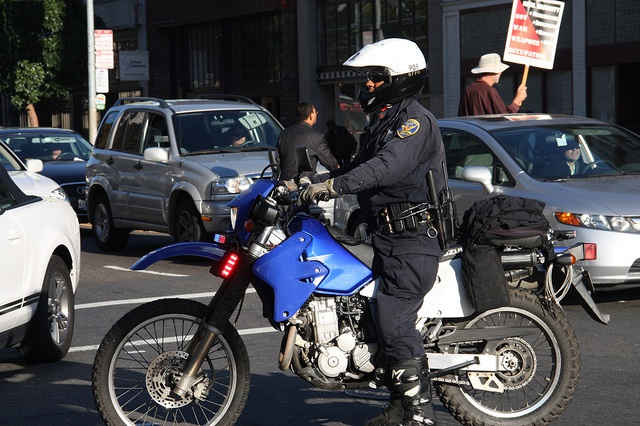Describe the objects in this image and their specific colors. I can see motorcycle in black, gray, white, and darkgray tones, people in black, gray, and white tones, car in black, gray, and darkgray tones, car in black, gray, and navy tones, and car in black, white, gray, and darkgray tones in this image. 